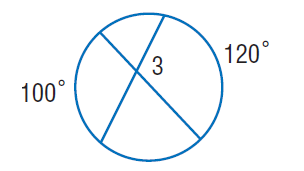Answer the mathemtical geometry problem and directly provide the correct option letter.
Question: Find \angle 3.
Choices: A: 100 B: 110 C: 120 D: 220 B 